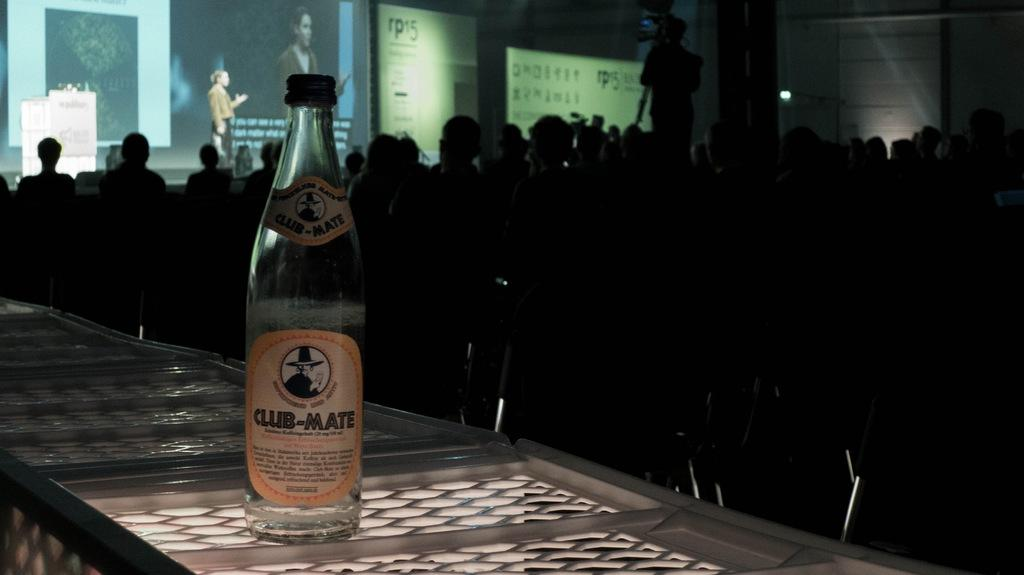Provide a one-sentence caption for the provided image. A large crowd of people are cast in a dark shadow with a bottle of Club-Mate at the forefront of the image. 